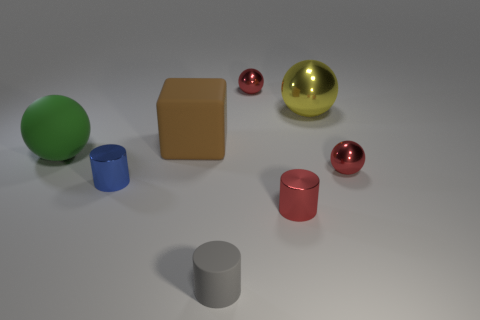Is the big ball to the right of the tiny rubber thing made of the same material as the large ball on the left side of the large metallic object?
Ensure brevity in your answer.  No. There is a large thing on the right side of the tiny red metal ball that is to the left of the tiny metal sphere in front of the brown rubber cube; what shape is it?
Make the answer very short. Sphere. Are there more gray cylinders than tiny balls?
Ensure brevity in your answer.  No. Are any metal things visible?
Provide a short and direct response. Yes. What number of objects are large balls that are on the left side of the red cylinder or green rubber things that are to the left of the yellow thing?
Provide a short and direct response. 1. Are there fewer big yellow metal things than purple metallic cylinders?
Your answer should be compact. No. There is a large green sphere; are there any red metallic things behind it?
Your response must be concise. Yes. Are the blue object and the large block made of the same material?
Provide a succinct answer. No. There is another small shiny thing that is the same shape as the blue thing; what color is it?
Offer a terse response. Red. What number of purple cylinders are the same material as the blue thing?
Offer a terse response. 0. 